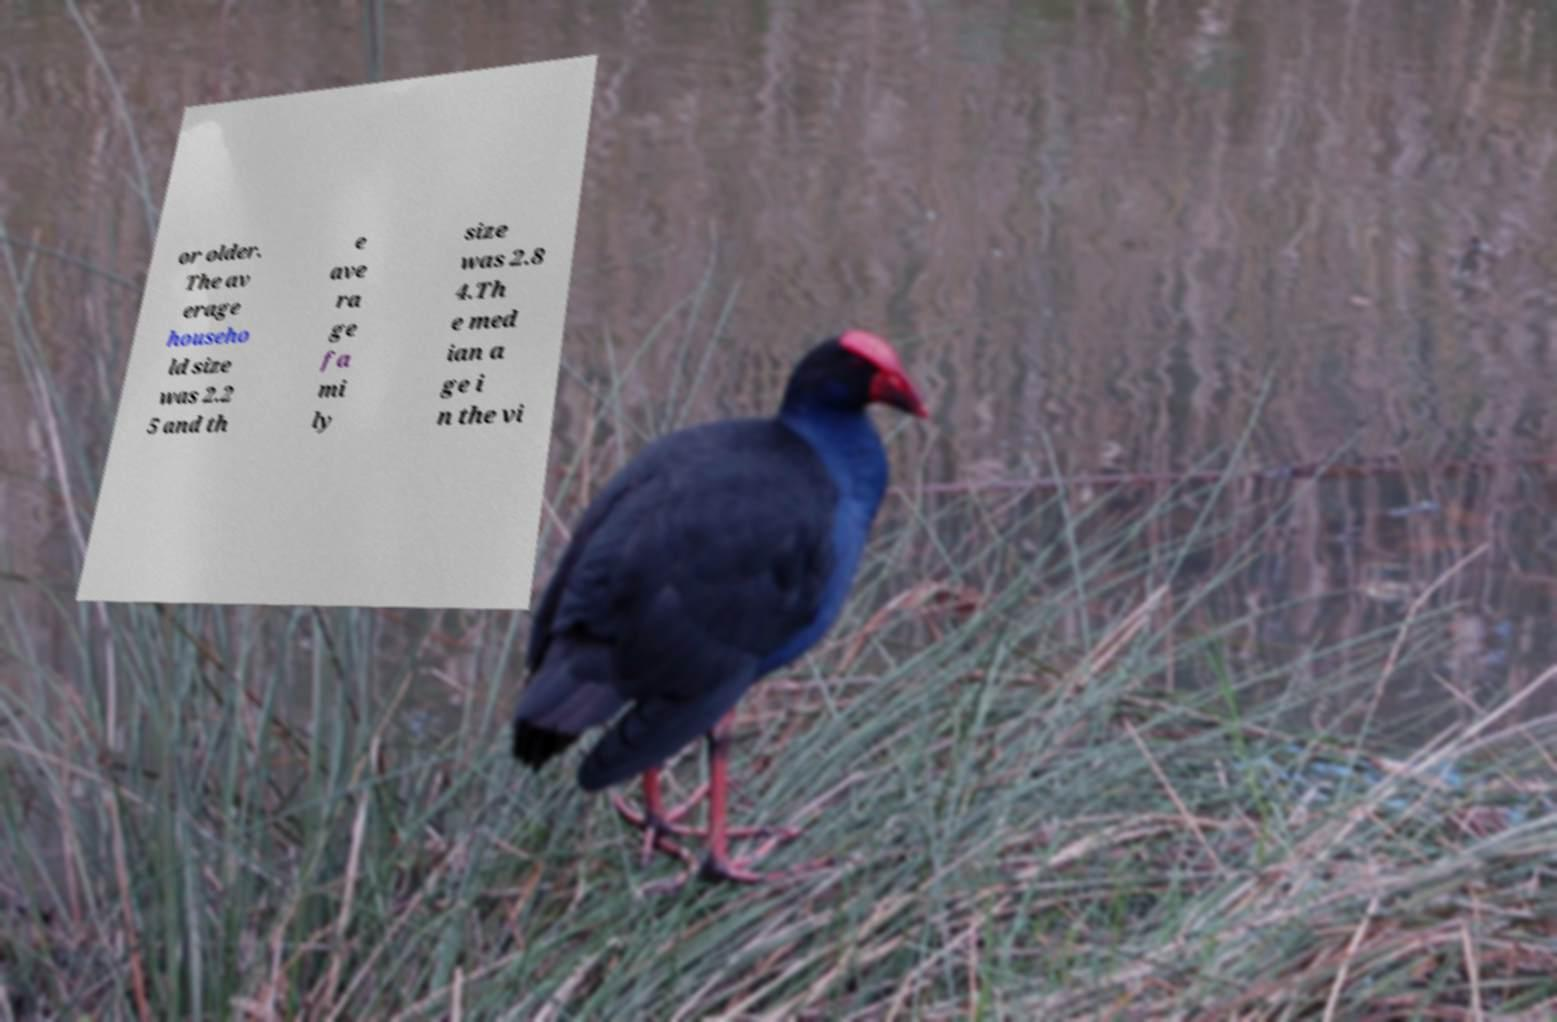Can you read and provide the text displayed in the image?This photo seems to have some interesting text. Can you extract and type it out for me? or older. The av erage househo ld size was 2.2 5 and th e ave ra ge fa mi ly size was 2.8 4.Th e med ian a ge i n the vi 